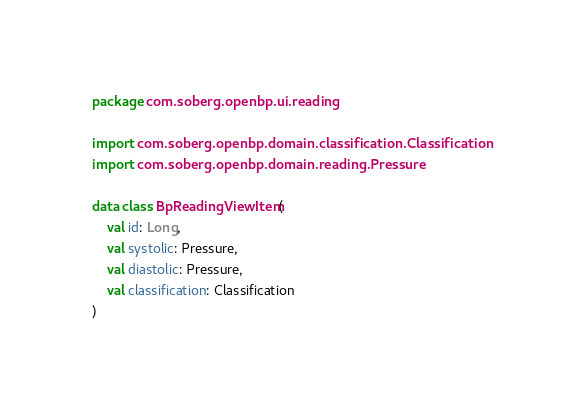Convert code to text. <code><loc_0><loc_0><loc_500><loc_500><_Kotlin_>package com.soberg.openbp.ui.reading

import com.soberg.openbp.domain.classification.Classification
import com.soberg.openbp.domain.reading.Pressure

data class BpReadingViewItem(
    val id: Long,
    val systolic: Pressure,
    val diastolic: Pressure,
    val classification: Classification
)</code> 